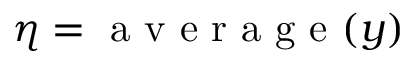Convert formula to latex. <formula><loc_0><loc_0><loc_500><loc_500>\eta = a v e r a g e ( y )</formula> 